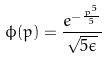<formula> <loc_0><loc_0><loc_500><loc_500>\phi ( p ) = \frac { e ^ { - \frac { p ^ { 5 } } { 5 } } } { \sqrt { 5 \epsilon } }</formula> 